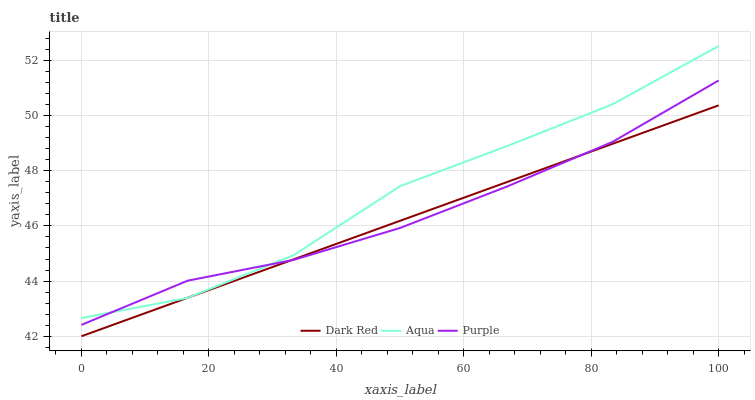Does Aqua have the minimum area under the curve?
Answer yes or no. No. Does Dark Red have the maximum area under the curve?
Answer yes or no. No. Is Aqua the smoothest?
Answer yes or no. No. Is Dark Red the roughest?
Answer yes or no. No. Does Aqua have the lowest value?
Answer yes or no. No. Does Dark Red have the highest value?
Answer yes or no. No. 